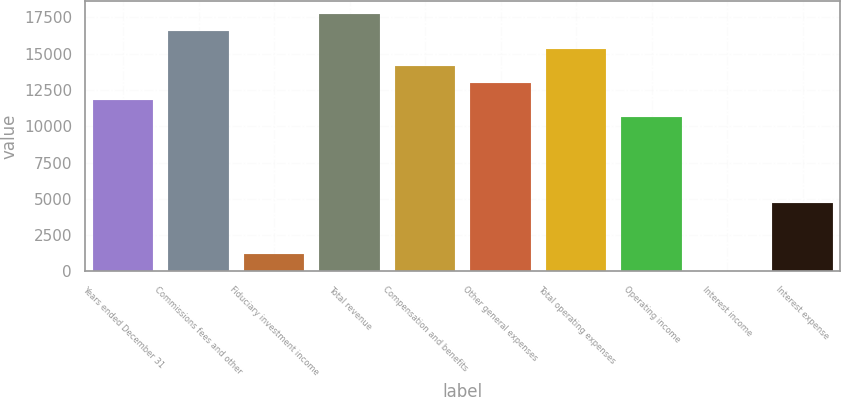<chart> <loc_0><loc_0><loc_500><loc_500><bar_chart><fcel>Years ended December 31<fcel>Commissions fees and other<fcel>Fiduciary investment income<fcel>Total revenue<fcel>Compensation and benefits<fcel>Other general expenses<fcel>Total operating expenses<fcel>Operating income<fcel>Interest income<fcel>Interest expense<nl><fcel>11815<fcel>16537.4<fcel>1189.6<fcel>17718<fcel>14176.2<fcel>12995.6<fcel>15356.8<fcel>10634.4<fcel>9<fcel>4731.4<nl></chart> 